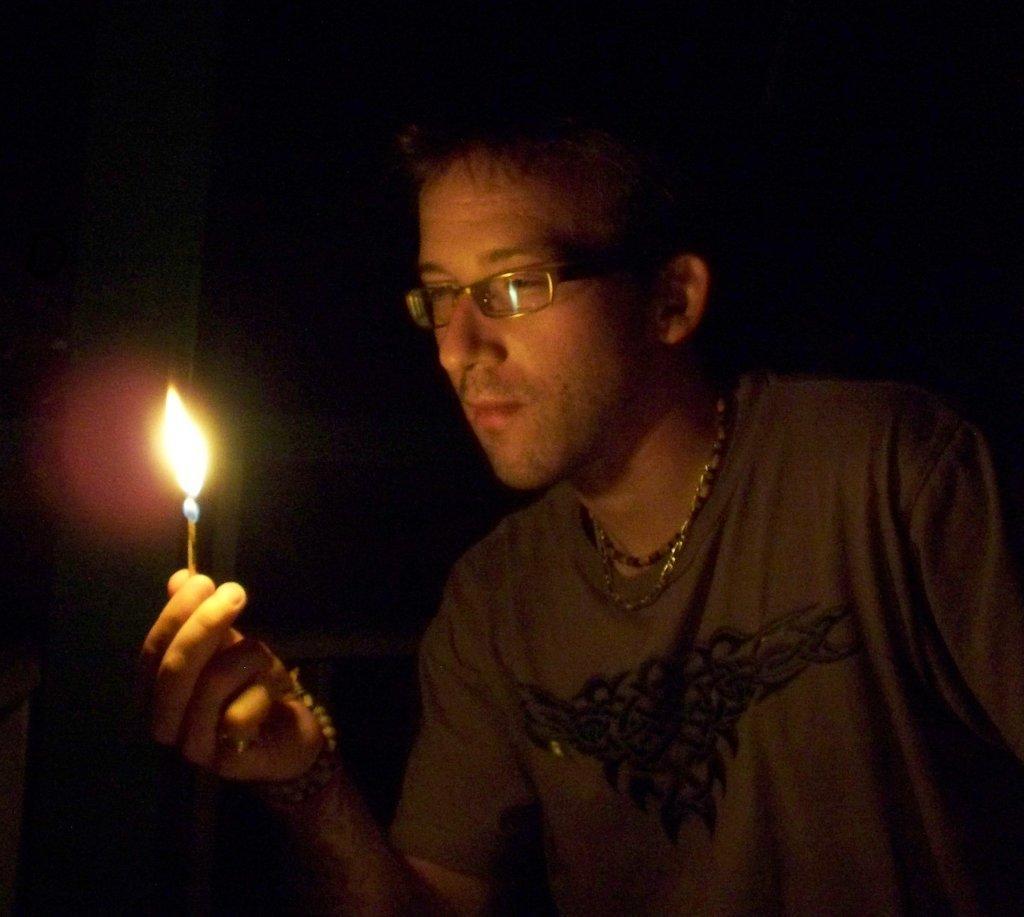Could you give a brief overview of what you see in this image? In this image we can see a man wearing the glasses and also the t shirt and he is holding the match stick with the flame and the background is in black color. 